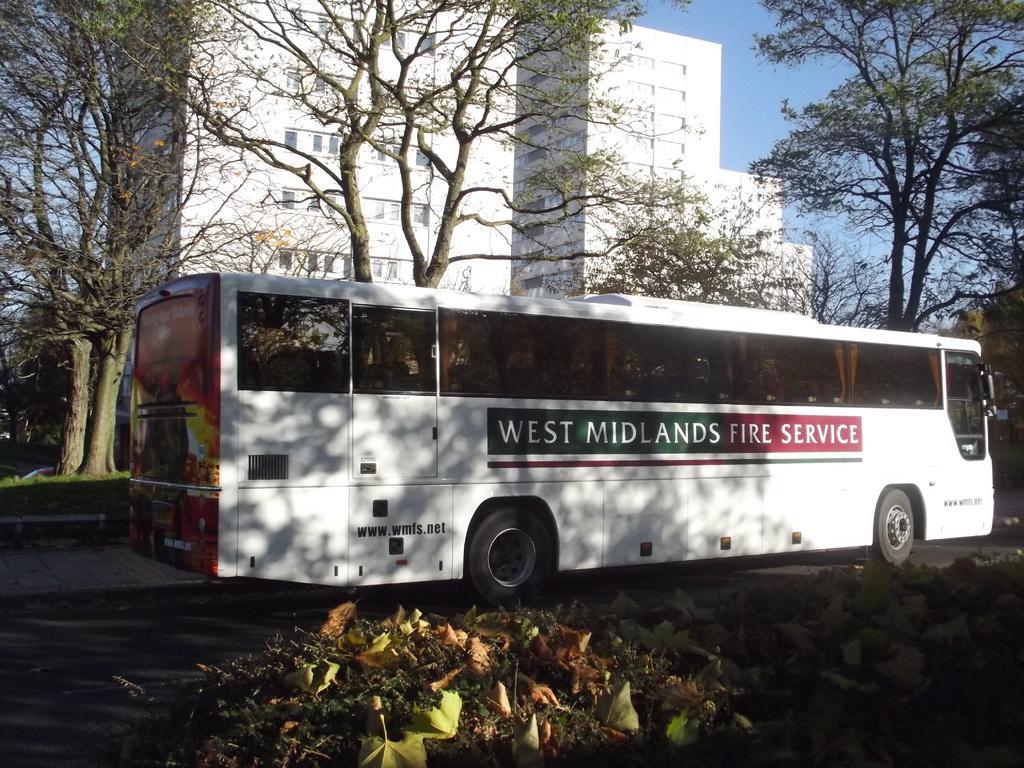In one or two sentences, can you explain what this image depicts? In this image, I can see a bus on the road. These are the buildings, which are white in color. I can see the trees with branches and leaves. At the bottom of the image, these look like the bushes. 